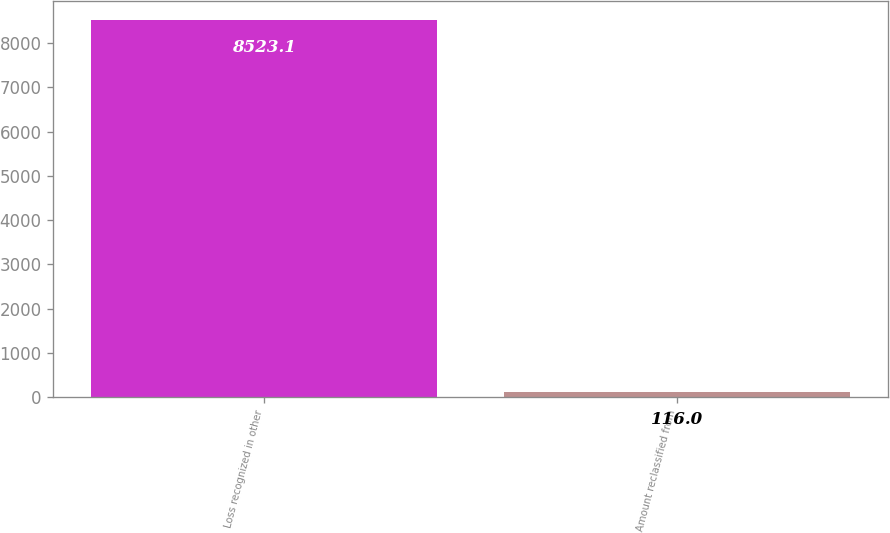<chart> <loc_0><loc_0><loc_500><loc_500><bar_chart><fcel>Loss recognized in other<fcel>Amount reclassified from<nl><fcel>8523.1<fcel>116<nl></chart> 